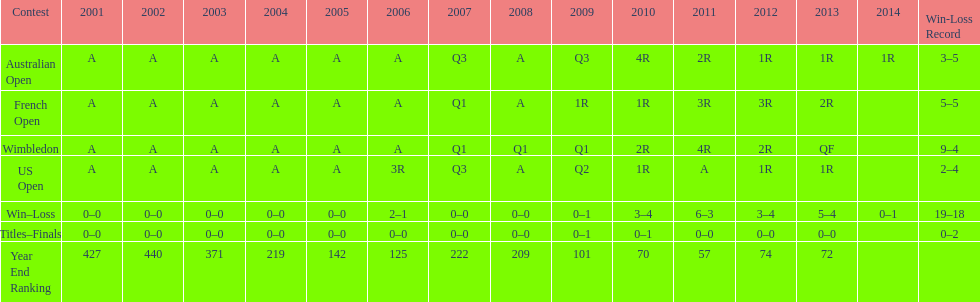Which tournament has the largest total win record? Wimbledon. 